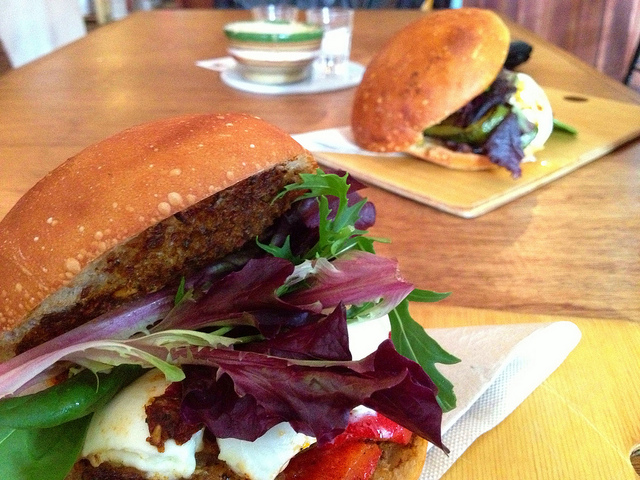What kind of occasion might these sandwiches be suitable for? These sandwiches would be perfect for a variety of occasions. Their gourmet presentation suggests they could be enjoyed at a casual dining restaurant or a trendy cafe. They would also make great picnic food or a satisfying meal for a lunch break that's a little more special. 